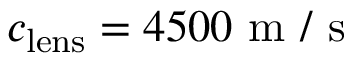Convert formula to latex. <formula><loc_0><loc_0><loc_500><loc_500>c _ { l e n s } = 4 5 0 0 m / s</formula> 